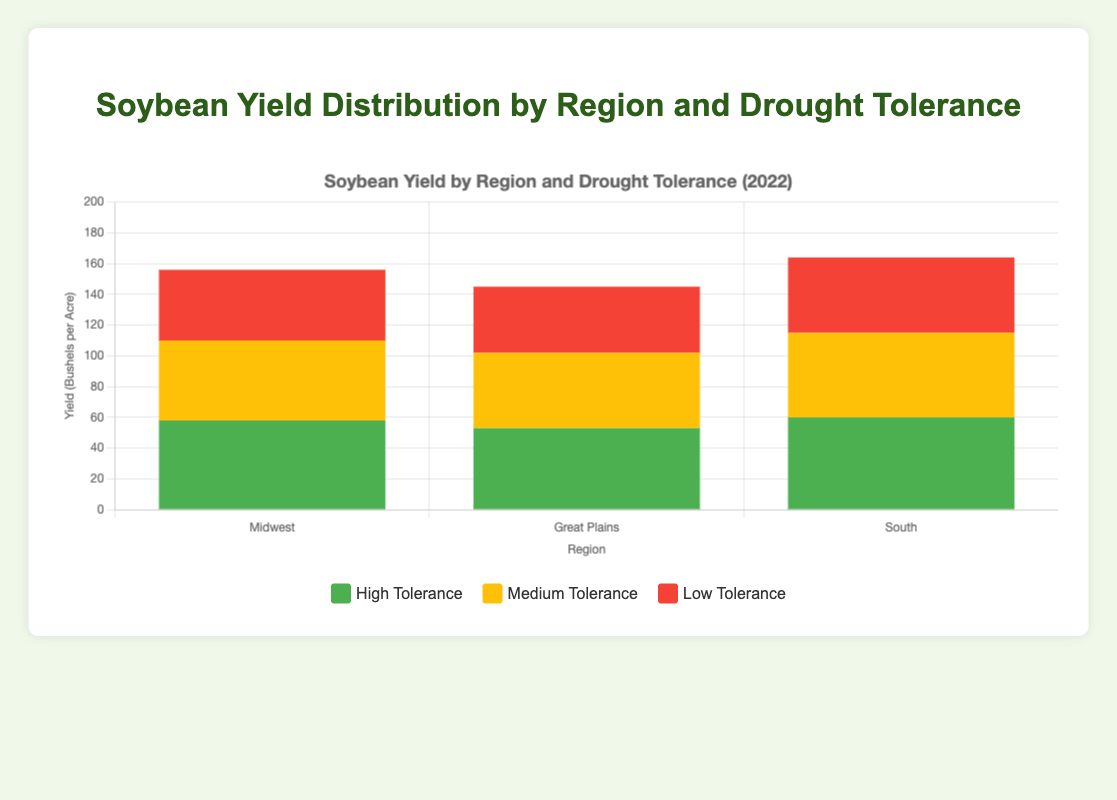Which region had the highest yield from strains with high drought tolerance? To determine this, compare the heights of the sections colored in green (for high drought tolerance) across all regions (Midwest, Great Plains, and South). The South region has the highest green section, representing a 2022 yield of 60 bushels per acre for high drought tolerance.
Answer: South How does the yield of medium drought-tolerant strains in the Midwest compare to those in the Great Plains? Examine the yellow sections for both regions. In the Midwest, the yield for medium drought tolerance is 52 bushels per acre, whereas in the Great Plains, it is 49 bushels per acre. Comparing these, the Midwest has a higher yield.
Answer: Midwest's yield is higher What is the total yield for all strains in the South region? Sum the yields for high, medium, and low drought tolerance in the South: 60 (high) + 55 (medium) + 49 (low) gives a total yield of 164 bushels per acre.
Answer: 164 bushels per acre Which drought tolerance level has the lowest yield in the South? Compare the yield values for the green (high), yellow (medium), and red (low) sections in the South region. The red section (49 bushels per acre) is the lowest.
Answer: Low drought tolerance Which region showed the highest yield for low drought-tolerant strains? Look at the red sections for all regions. The Midwest has the highest red section with a yield of 46 bushels per acre.
Answer: Midwest What is the difference in yield between high and low drought tolerance strains in the Great Plains? Find the values for both high and low drought tolerance in the Great Plains: 53 (high) - 43 (low), resulting in a difference of 10 bushels per acre.
Answer: 10 bushels per acre Rank the regions from highest to lowest total yield for all drought tolerance levels. Calculate the total yield for each region by summing the values for high, medium, and low drought tolerance: Midwest (58+52+46=156), Great Plains (53+49+43=145), and South (60+55+49=164). Rank them based on these totals.
Answer: South, Midwest, Great Plains Which strain in the Midwest has the highest yield? Examine the green, yellow, and red sections within the Midwest. The green section (Pioneer P22T41R) has the highest yield of 58 bushels per acre.
Answer: Pioneer P22T41R 